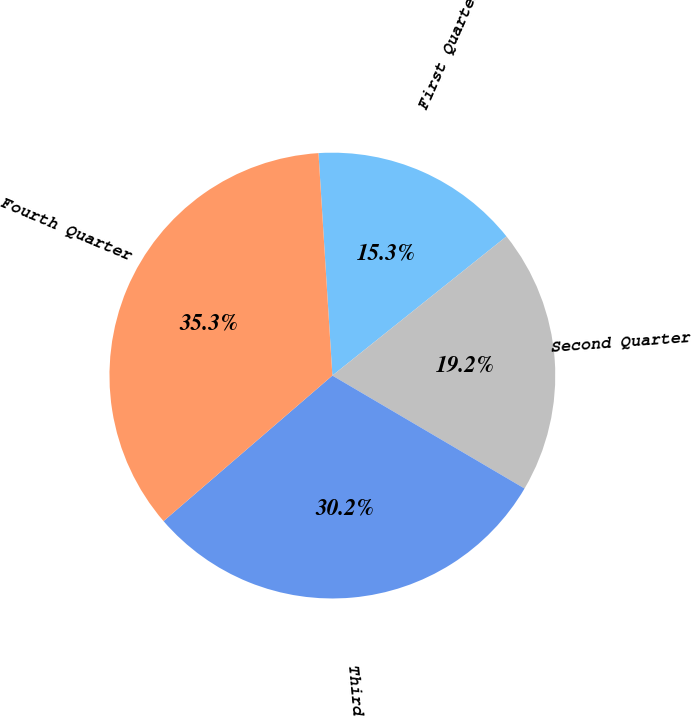Convert chart. <chart><loc_0><loc_0><loc_500><loc_500><pie_chart><fcel>First Quarter<fcel>Second Quarter<fcel>Third Quarter<fcel>Fourth Quarter<nl><fcel>15.26%<fcel>19.19%<fcel>30.22%<fcel>35.33%<nl></chart> 